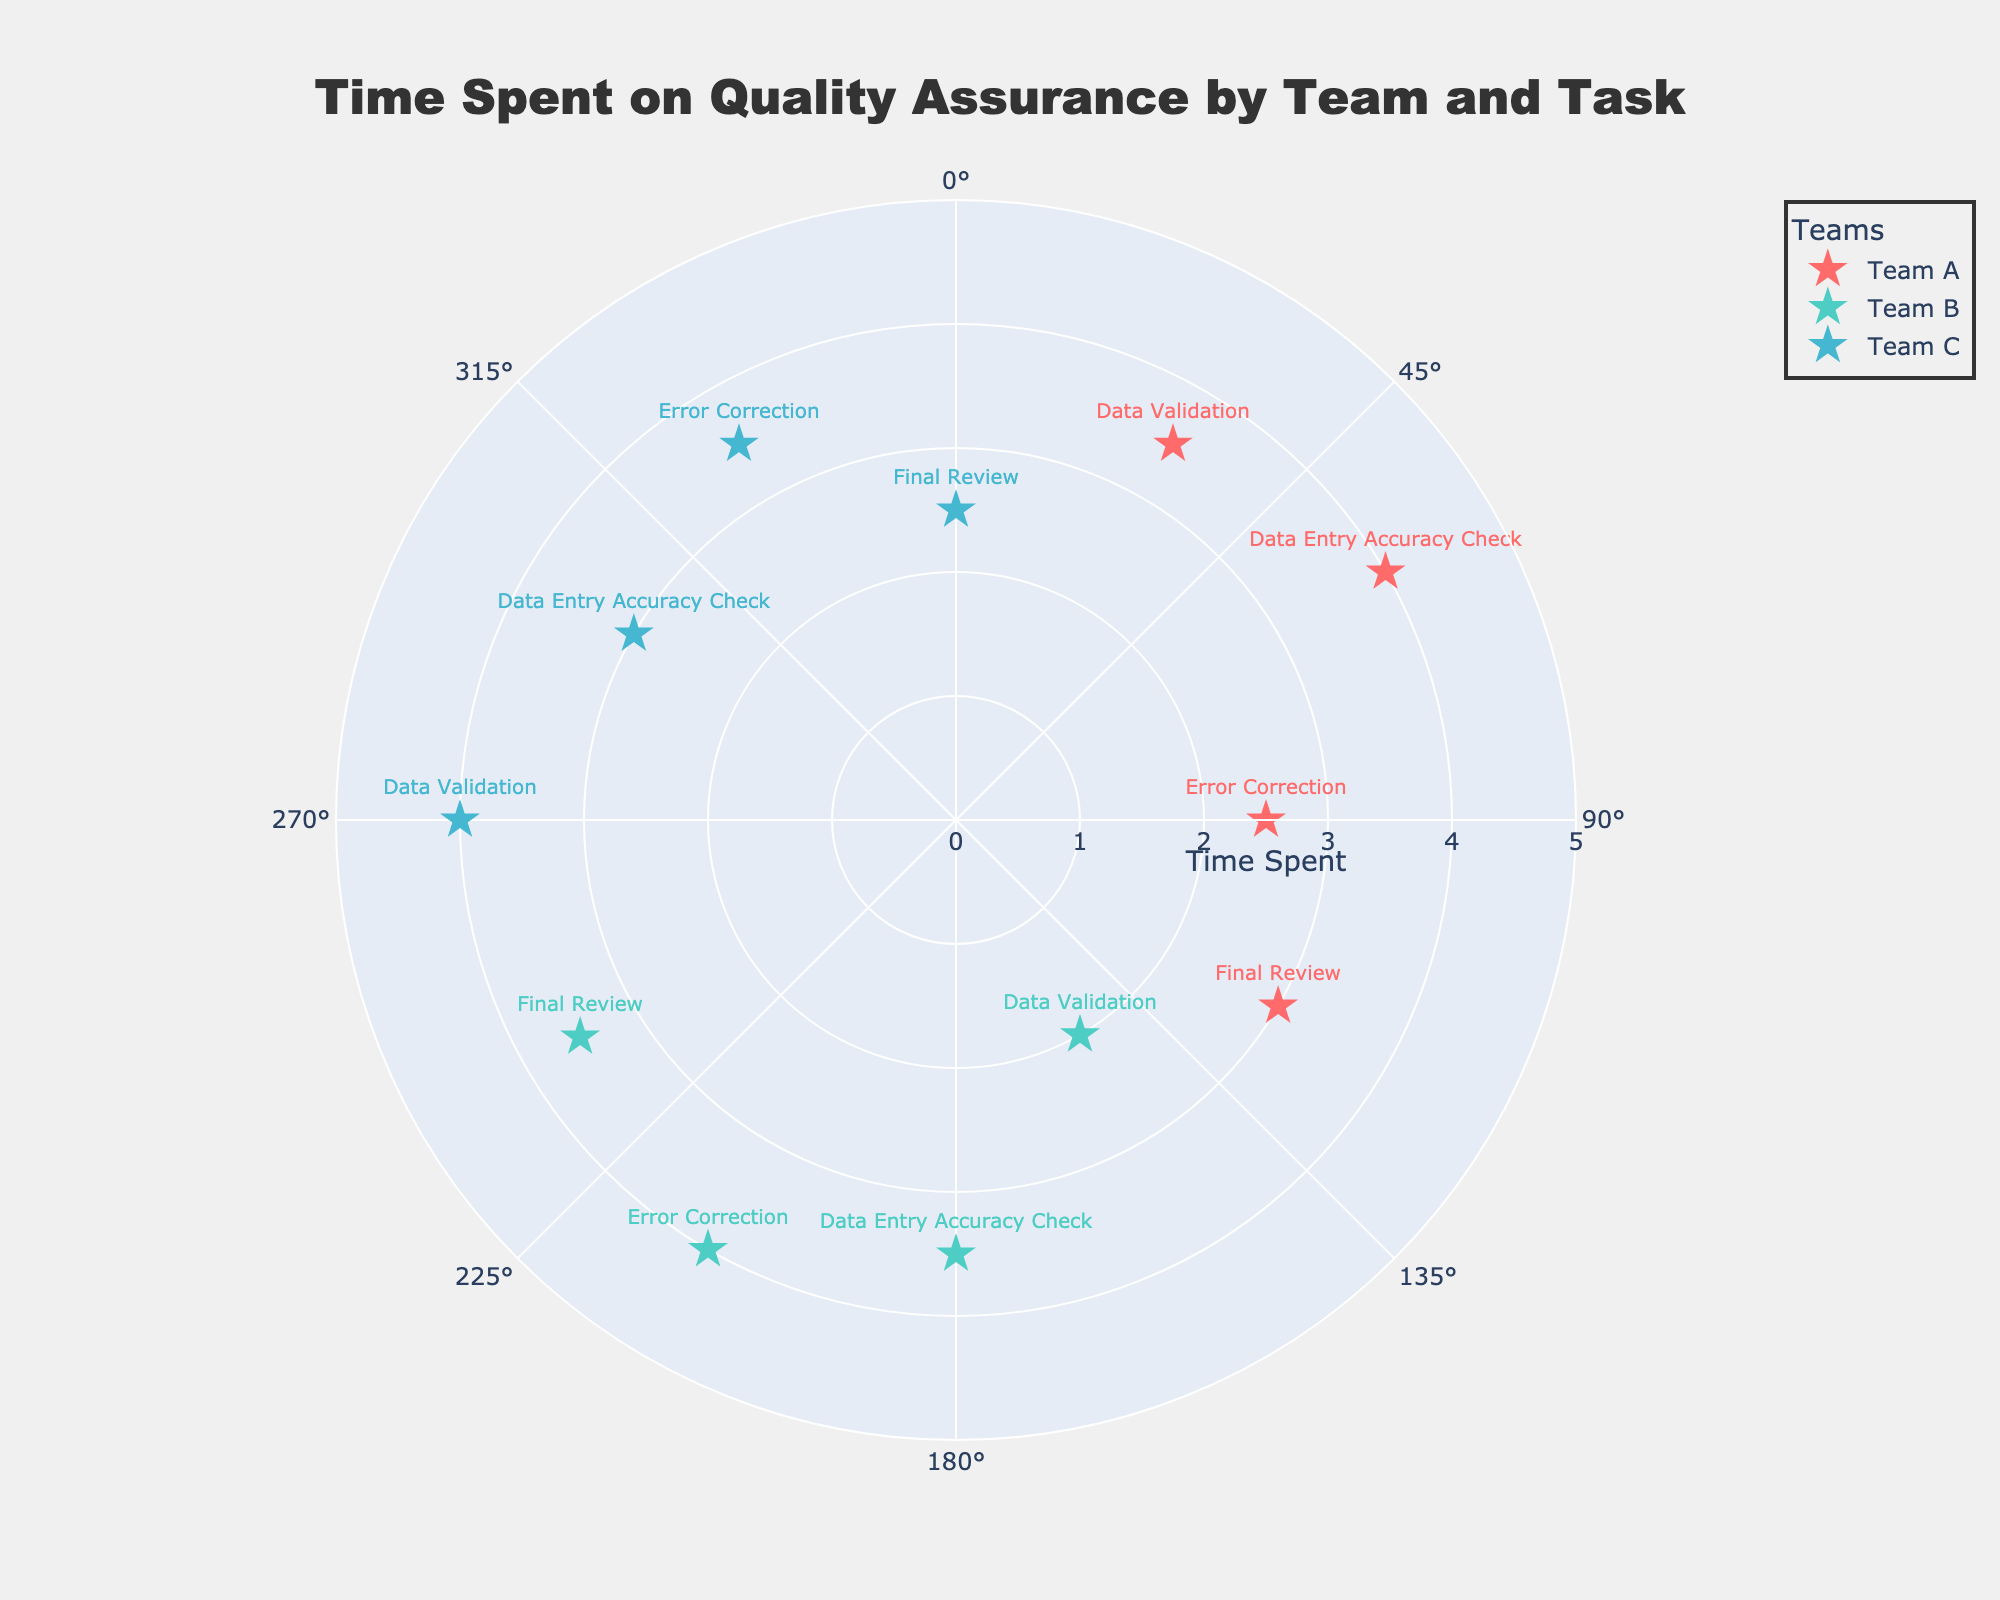What's the title of the chart? The title is found at the top of the chart and is highlighted by a larger font size. It reads "Time Spent on Quality Assurance by Team and Task."
Answer: Time Spent on Quality Assurance by Team and Task How many teams are displayed in the chart? The legend on the right-hand side of the chart shows the names of all teams. There are three teams listed: Team A, Team B, and Team C.
Answer: 3 Which team spent the most time on Data Entry Accuracy Check? By looking at the points labeled "Data Entry Accuracy Check" for each team, Team A has a radius of 4.0, Team B has a radius of 3.5, and Team C has a radius of 3.0. Team A spent the most time.
Answer: Team A What is the difference in time spent on Final Review between Team A and Team C? Team A spent 3.0 units of time on Final Review (radius at 120 degrees), and Team C spent 2.5 units of time on Final Review (radius at 360 degrees). The difference is 3.0 - 2.5 = 0.5 units.
Answer: 0.5 units Which task did Team B spend the least time on? Reviewing Team B's tasks and their corresponding radii: Data Validation (2.0), Data Entry Accuracy Check (3.5), Error Correction (4.0), and Final Review (3.5). The task with the smallest radius is Data Validation.
Answer: Data Validation Who spent more time on Error Correction, Team A or Team C? Team A's Error Correction is at a radius of 2.5 (90 degrees), and Team C's Error Correction is at a radius of 3.5 (330 degrees). Team C spent more time on Error Correction.
Answer: Team C What's the average time spent on tasks by Team B? Team B's times are: Data Validation (2.0), Data Entry Accuracy Check (3.5), Error Correction (4.0), and Final Review (3.5). Sum: 2.0 + 3.5 + 4.0 + 3.5 = 13. Average: 13 / 4 = 3.25 units.
Answer: 3.25 units Which team spent equal time on more than one task? Team B spent 3.5 units on both Data Entry Accuracy Check and Final Review. None of the other teams have equal times for different tasks.
Answer: Team B What is the range of time spent on tasks by Team C? Team C's times are: Data Validation (4.0), Data Entry Accuracy Check (3.0), Error Correction (3.5), and Final Review (2.5). The range is the difference between the maximum (4.0) and minimum (2.5) values, which is 1.5 units.
Answer: 1.5 units How many tasks did Team A spend more than 3 units of time on? Team A's tasks and corresponding times: Data Validation (3.5), Data Entry Accuracy Check (4.0), Error Correction (2.5), and Final Review (3.0). The tasks above 3 units are Data Validation, Data Entry Accuracy Check, and Final Review.
Answer: 3 